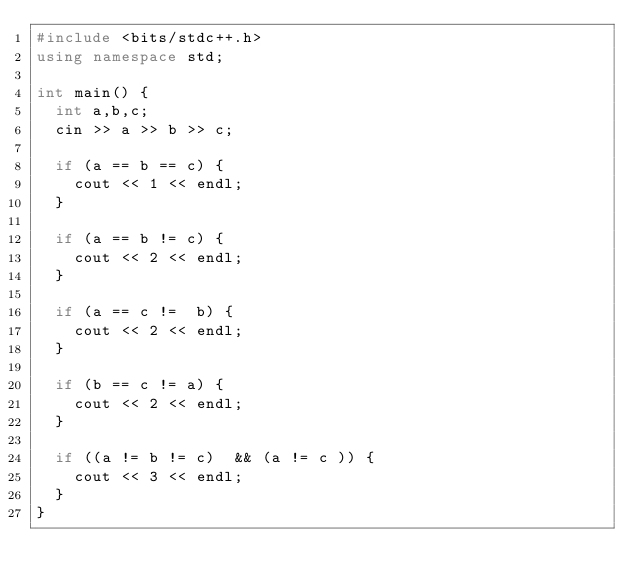<code> <loc_0><loc_0><loc_500><loc_500><_C++_>#include <bits/stdc++.h>
using namespace std;

int main() {
  int a,b,c;
  cin >> a >> b >> c;

  if (a == b == c) {
    cout << 1 << endl;
  }

  if (a == b != c) {
    cout << 2 << endl;
  }

  if (a == c !=  b) {
    cout << 2 << endl;
  }
  
  if (b == c != a) {
    cout << 2 << endl;
  }

  if ((a != b != c)  && (a != c )) {
    cout << 3 << endl;
  }
}
</code> 